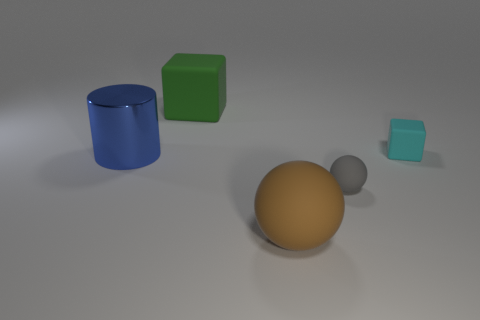Add 3 red matte things. How many objects exist? 8 Subtract all cylinders. How many objects are left? 4 Add 1 small brown rubber objects. How many small brown rubber objects exist? 1 Subtract 1 blue cylinders. How many objects are left? 4 Subtract all blue metal cylinders. Subtract all green rubber cubes. How many objects are left? 3 Add 3 cyan things. How many cyan things are left? 4 